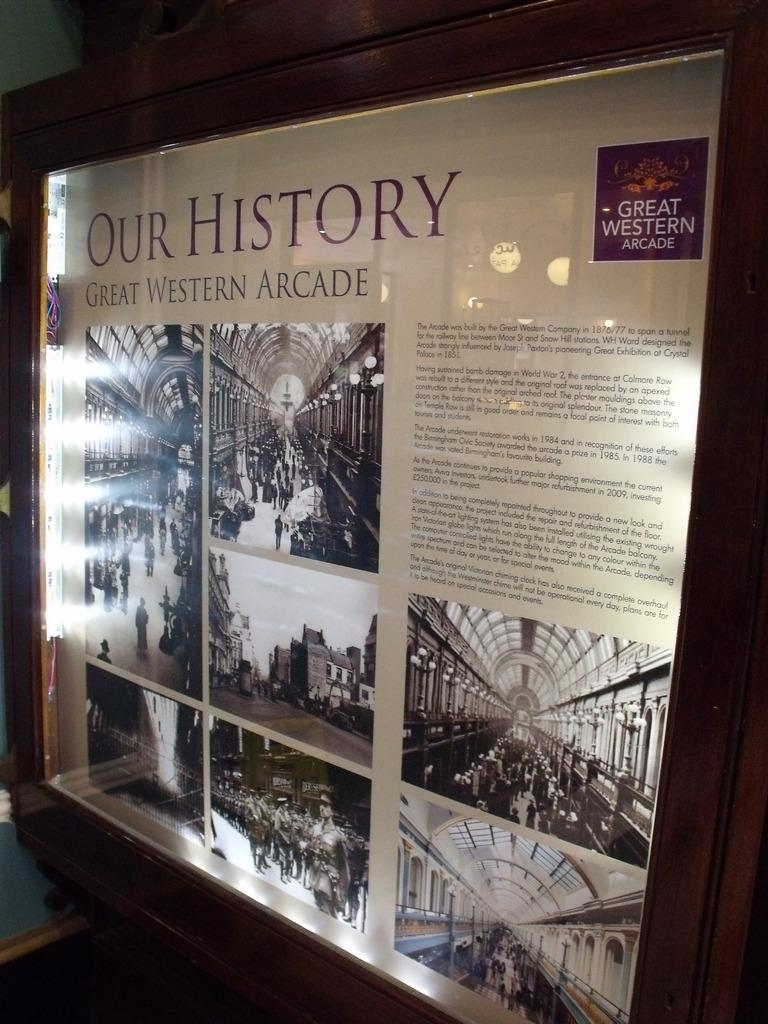<image>
Relay a brief, clear account of the picture shown. An information board behind glass about the Great Western Arcade features black and white pictures as well. 